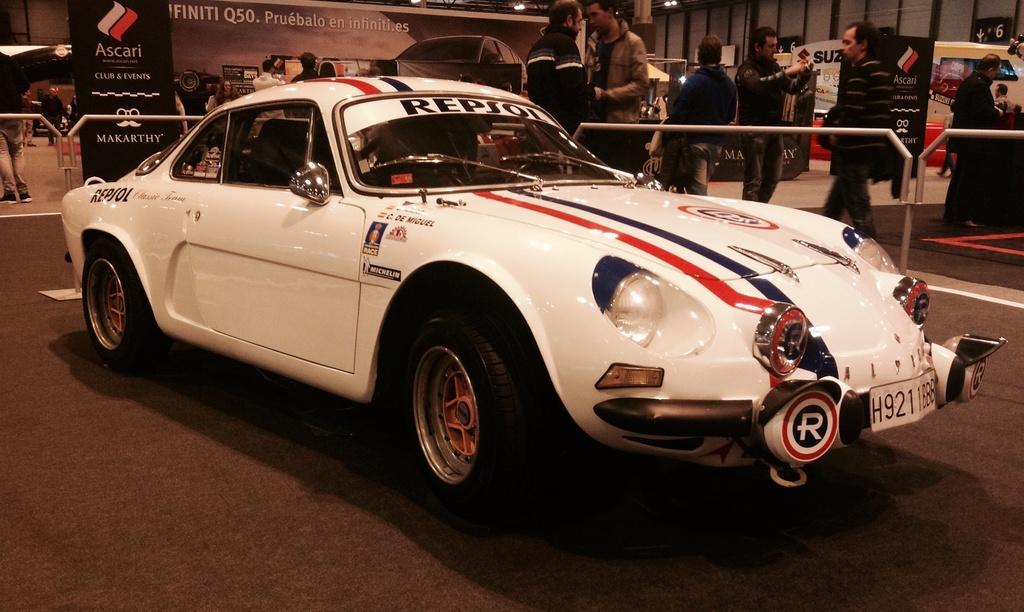Could you give a brief overview of what you see in this image? This picture contains a white car. Behind that, we see people are standing. We even see a black color board with some text written on it. In the background, we see a banner with photos and camera. Behind the car, we see an iron rod. 